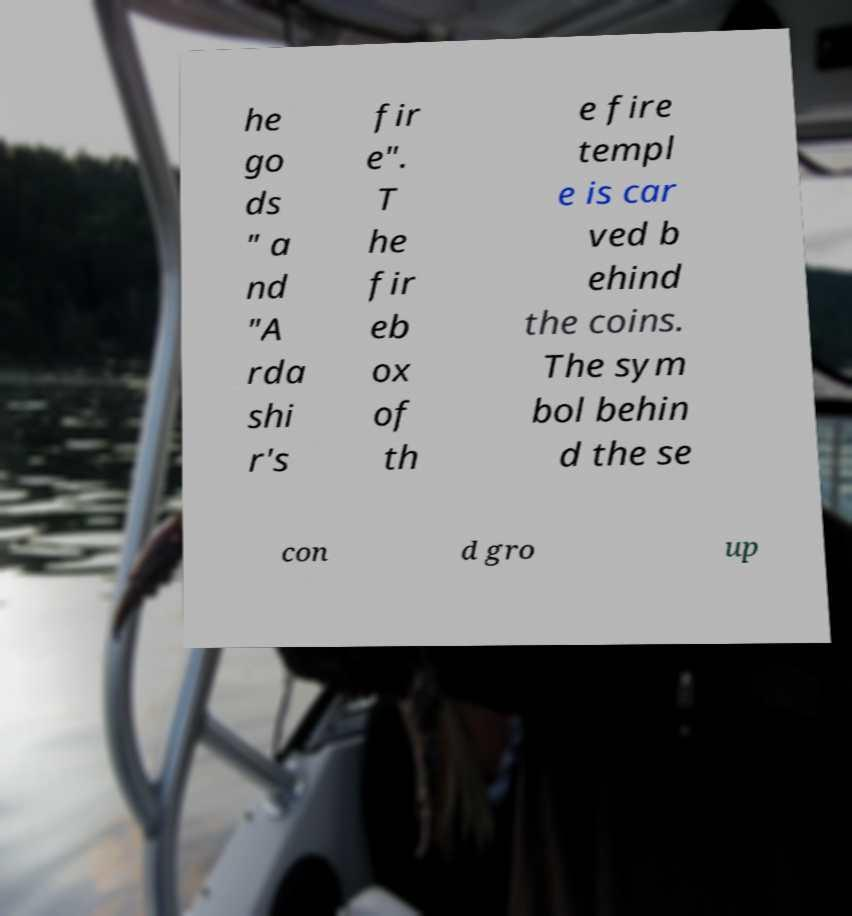Could you assist in decoding the text presented in this image and type it out clearly? he go ds " a nd "A rda shi r's fir e". T he fir eb ox of th e fire templ e is car ved b ehind the coins. The sym bol behin d the se con d gro up 